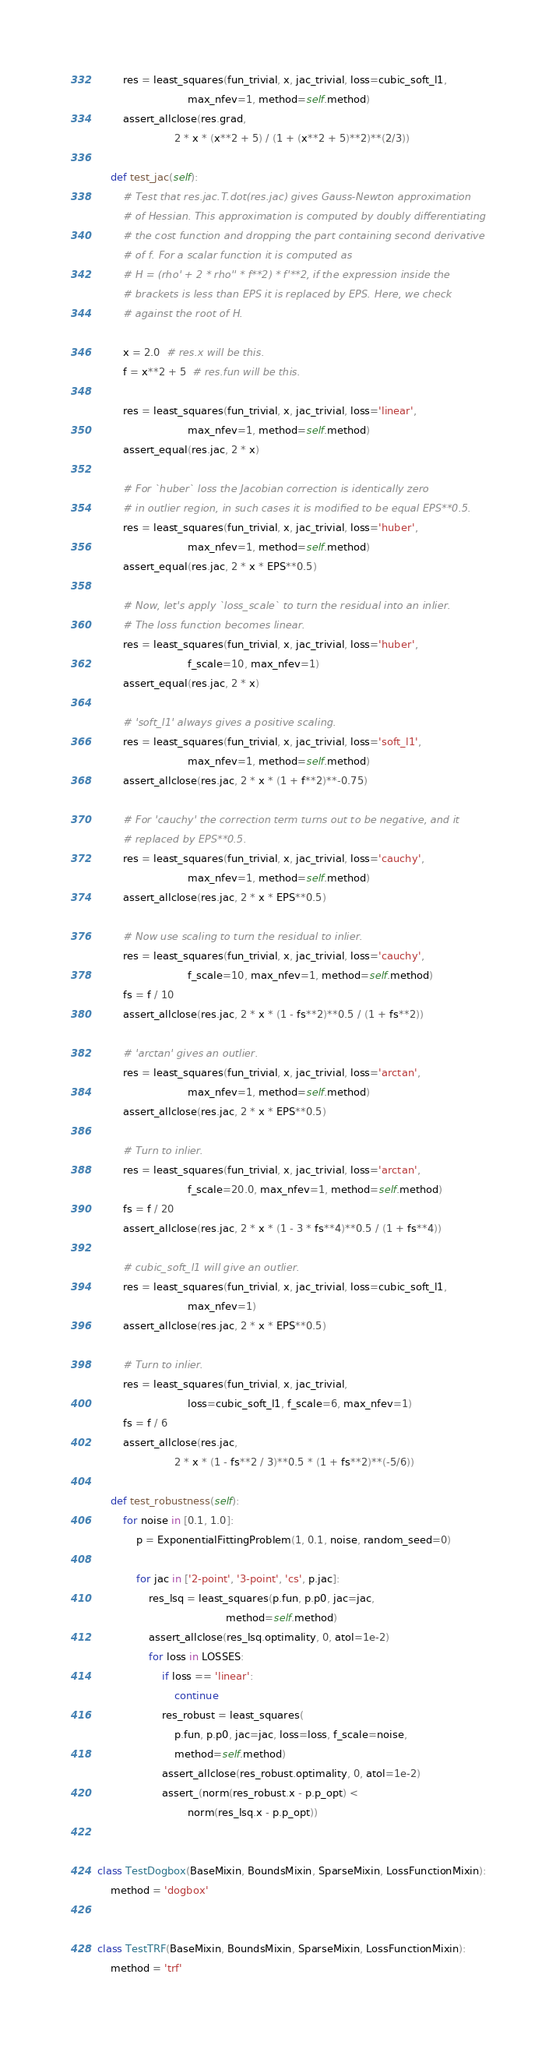<code> <loc_0><loc_0><loc_500><loc_500><_Python_>
        res = least_squares(fun_trivial, x, jac_trivial, loss=cubic_soft_l1,
                            max_nfev=1, method=self.method)
        assert_allclose(res.grad,
                        2 * x * (x**2 + 5) / (1 + (x**2 + 5)**2)**(2/3))

    def test_jac(self):
        # Test that res.jac.T.dot(res.jac) gives Gauss-Newton approximation
        # of Hessian. This approximation is computed by doubly differentiating
        # the cost function and dropping the part containing second derivative
        # of f. For a scalar function it is computed as
        # H = (rho' + 2 * rho'' * f**2) * f'**2, if the expression inside the
        # brackets is less than EPS it is replaced by EPS. Here, we check
        # against the root of H.

        x = 2.0  # res.x will be this.
        f = x**2 + 5  # res.fun will be this.

        res = least_squares(fun_trivial, x, jac_trivial, loss='linear',
                            max_nfev=1, method=self.method)
        assert_equal(res.jac, 2 * x)

        # For `huber` loss the Jacobian correction is identically zero
        # in outlier region, in such cases it is modified to be equal EPS**0.5.
        res = least_squares(fun_trivial, x, jac_trivial, loss='huber',
                            max_nfev=1, method=self.method)
        assert_equal(res.jac, 2 * x * EPS**0.5)

        # Now, let's apply `loss_scale` to turn the residual into an inlier.
        # The loss function becomes linear.
        res = least_squares(fun_trivial, x, jac_trivial, loss='huber',
                            f_scale=10, max_nfev=1)
        assert_equal(res.jac, 2 * x)

        # 'soft_l1' always gives a positive scaling.
        res = least_squares(fun_trivial, x, jac_trivial, loss='soft_l1',
                            max_nfev=1, method=self.method)
        assert_allclose(res.jac, 2 * x * (1 + f**2)**-0.75)

        # For 'cauchy' the correction term turns out to be negative, and it
        # replaced by EPS**0.5.
        res = least_squares(fun_trivial, x, jac_trivial, loss='cauchy',
                            max_nfev=1, method=self.method)
        assert_allclose(res.jac, 2 * x * EPS**0.5)

        # Now use scaling to turn the residual to inlier.
        res = least_squares(fun_trivial, x, jac_trivial, loss='cauchy',
                            f_scale=10, max_nfev=1, method=self.method)
        fs = f / 10
        assert_allclose(res.jac, 2 * x * (1 - fs**2)**0.5 / (1 + fs**2))

        # 'arctan' gives an outlier.
        res = least_squares(fun_trivial, x, jac_trivial, loss='arctan',
                            max_nfev=1, method=self.method)
        assert_allclose(res.jac, 2 * x * EPS**0.5)

        # Turn to inlier.
        res = least_squares(fun_trivial, x, jac_trivial, loss='arctan',
                            f_scale=20.0, max_nfev=1, method=self.method)
        fs = f / 20
        assert_allclose(res.jac, 2 * x * (1 - 3 * fs**4)**0.5 / (1 + fs**4))

        # cubic_soft_l1 will give an outlier.
        res = least_squares(fun_trivial, x, jac_trivial, loss=cubic_soft_l1,
                            max_nfev=1)
        assert_allclose(res.jac, 2 * x * EPS**0.5)

        # Turn to inlier.
        res = least_squares(fun_trivial, x, jac_trivial,
                            loss=cubic_soft_l1, f_scale=6, max_nfev=1)
        fs = f / 6
        assert_allclose(res.jac,
                        2 * x * (1 - fs**2 / 3)**0.5 * (1 + fs**2)**(-5/6))

    def test_robustness(self):
        for noise in [0.1, 1.0]:
            p = ExponentialFittingProblem(1, 0.1, noise, random_seed=0)

            for jac in ['2-point', '3-point', 'cs', p.jac]:
                res_lsq = least_squares(p.fun, p.p0, jac=jac,
                                        method=self.method)
                assert_allclose(res_lsq.optimality, 0, atol=1e-2)
                for loss in LOSSES:
                    if loss == 'linear':
                        continue
                    res_robust = least_squares(
                        p.fun, p.p0, jac=jac, loss=loss, f_scale=noise,
                        method=self.method)
                    assert_allclose(res_robust.optimality, 0, atol=1e-2)
                    assert_(norm(res_robust.x - p.p_opt) <
                            norm(res_lsq.x - p.p_opt))


class TestDogbox(BaseMixin, BoundsMixin, SparseMixin, LossFunctionMixin):
    method = 'dogbox'


class TestTRF(BaseMixin, BoundsMixin, SparseMixin, LossFunctionMixin):
    method = 'trf'
</code> 